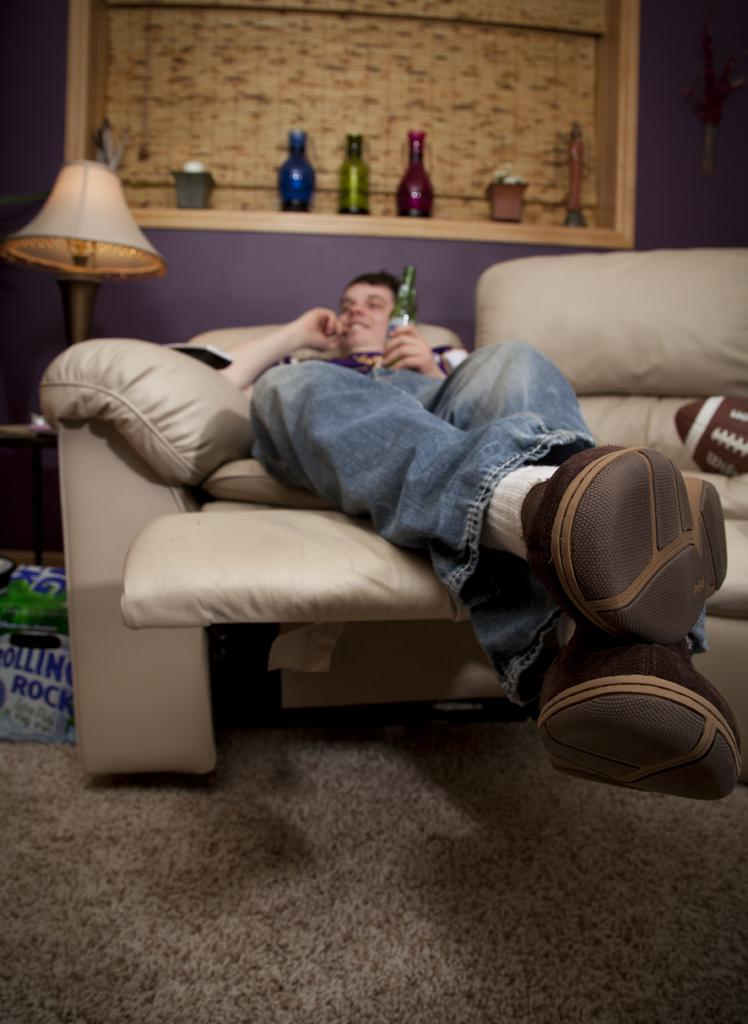What is the person in the image doing? There is a person lying on the couch in the image. What can be seen in the background of the image? There is a shelf and a lamp in the background of the image. What is on the shelf? There are bottles on the shelf in the image. What type of prison can be seen in the background of the image? There is no prison present in the image; it only features a person lying on the couch, a shelf, and a lamp in the background. 